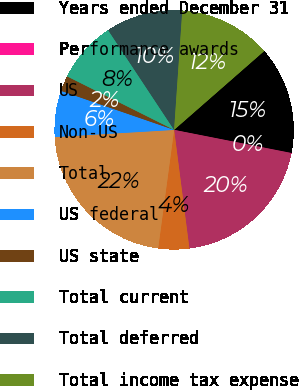Convert chart to OTSL. <chart><loc_0><loc_0><loc_500><loc_500><pie_chart><fcel>Years ended December 31<fcel>Performance awards<fcel>US<fcel>Non-US<fcel>Total<fcel>US federal<fcel>US state<fcel>Total current<fcel>Total deferred<fcel>Total income tax expense<nl><fcel>14.54%<fcel>0.02%<fcel>19.84%<fcel>4.17%<fcel>21.92%<fcel>6.24%<fcel>2.09%<fcel>8.32%<fcel>10.39%<fcel>12.47%<nl></chart> 